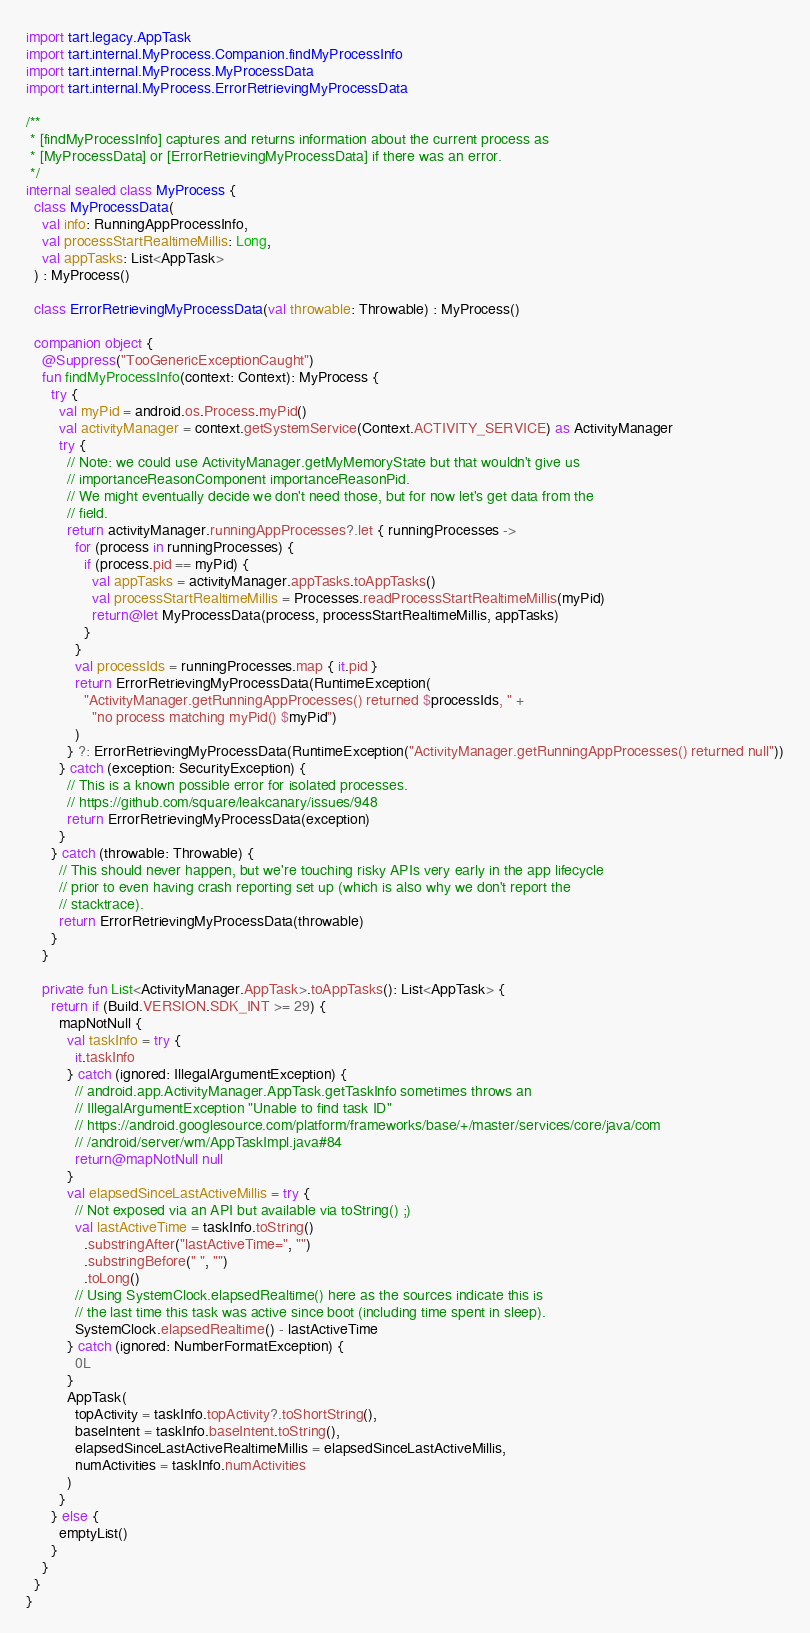<code> <loc_0><loc_0><loc_500><loc_500><_Kotlin_>import tart.legacy.AppTask
import tart.internal.MyProcess.Companion.findMyProcessInfo
import tart.internal.MyProcess.MyProcessData
import tart.internal.MyProcess.ErrorRetrievingMyProcessData

/**
 * [findMyProcessInfo] captures and returns information about the current process as
 * [MyProcessData] or [ErrorRetrievingMyProcessData] if there was an error.
 */
internal sealed class MyProcess {
  class MyProcessData(
    val info: RunningAppProcessInfo,
    val processStartRealtimeMillis: Long,
    val appTasks: List<AppTask>
  ) : MyProcess()

  class ErrorRetrievingMyProcessData(val throwable: Throwable) : MyProcess()

  companion object {
    @Suppress("TooGenericExceptionCaught")
    fun findMyProcessInfo(context: Context): MyProcess {
      try {
        val myPid = android.os.Process.myPid()
        val activityManager = context.getSystemService(Context.ACTIVITY_SERVICE) as ActivityManager
        try {
          // Note: we could use ActivityManager.getMyMemoryState but that wouldn't give us
          // importanceReasonComponent importanceReasonPid.
          // We might eventually decide we don't need those, but for now let's get data from the
          // field.
          return activityManager.runningAppProcesses?.let { runningProcesses ->
            for (process in runningProcesses) {
              if (process.pid == myPid) {
                val appTasks = activityManager.appTasks.toAppTasks()
                val processStartRealtimeMillis = Processes.readProcessStartRealtimeMillis(myPid)
                return@let MyProcessData(process, processStartRealtimeMillis, appTasks)
              }
            }
            val processIds = runningProcesses.map { it.pid }
            return ErrorRetrievingMyProcessData(RuntimeException(
              "ActivityManager.getRunningAppProcesses() returned $processIds, " +
                "no process matching myPid() $myPid")
            )
          } ?: ErrorRetrievingMyProcessData(RuntimeException("ActivityManager.getRunningAppProcesses() returned null"))
        } catch (exception: SecurityException) {
          // This is a known possible error for isolated processes.
          // https://github.com/square/leakcanary/issues/948
          return ErrorRetrievingMyProcessData(exception)
        }
      } catch (throwable: Throwable) {
        // This should never happen, but we're touching risky APIs very early in the app lifecycle
        // prior to even having crash reporting set up (which is also why we don't report the
        // stacktrace).
        return ErrorRetrievingMyProcessData(throwable)
      }
    }

    private fun List<ActivityManager.AppTask>.toAppTasks(): List<AppTask> {
      return if (Build.VERSION.SDK_INT >= 29) {
        mapNotNull {
          val taskInfo = try {
            it.taskInfo
          } catch (ignored: IllegalArgumentException) {
            // android.app.ActivityManager.AppTask.getTaskInfo sometimes throws an
            // IllegalArgumentException "Unable to find task ID"
            // https://android.googlesource.com/platform/frameworks/base/+/master/services/core/java/com
            // /android/server/wm/AppTaskImpl.java#84
            return@mapNotNull null
          }
          val elapsedSinceLastActiveMillis = try {
            // Not exposed via an API but available via toString() ;)
            val lastActiveTime = taskInfo.toString()
              .substringAfter("lastActiveTime=", "")
              .substringBefore(" ", "")
              .toLong()
            // Using SystemClock.elapsedRealtime() here as the sources indicate this is
            // the last time this task was active since boot (including time spent in sleep).
            SystemClock.elapsedRealtime() - lastActiveTime
          } catch (ignored: NumberFormatException) {
            0L
          }
          AppTask(
            topActivity = taskInfo.topActivity?.toShortString(),
            baseIntent = taskInfo.baseIntent.toString(),
            elapsedSinceLastActiveRealtimeMillis = elapsedSinceLastActiveMillis,
            numActivities = taskInfo.numActivities
          )
        }
      } else {
        emptyList()
      }
    }
  }
}</code> 